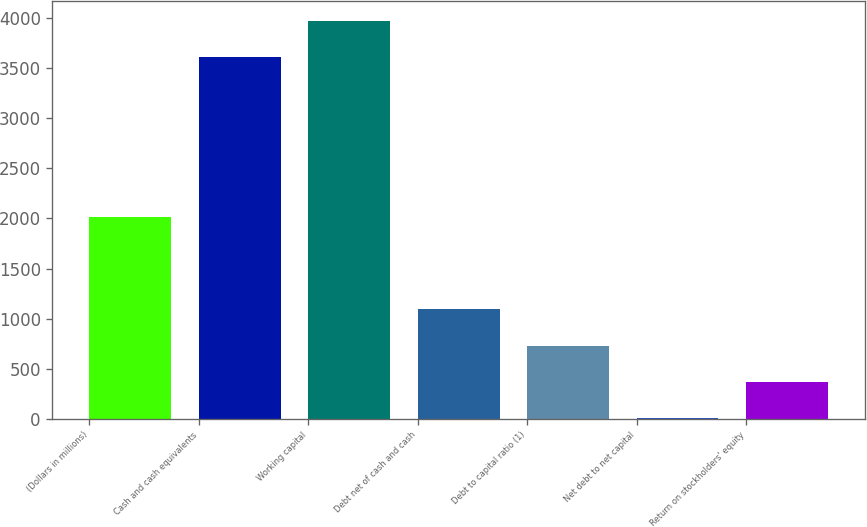Convert chart to OTSL. <chart><loc_0><loc_0><loc_500><loc_500><bar_chart><fcel>(Dollars in millions)<fcel>Cash and cash equivalents<fcel>Working capital<fcel>Debt net of cash and cash<fcel>Debt to capital ratio (1)<fcel>Net debt to net capital<fcel>Return on stockholders' equity<nl><fcel>2011<fcel>3612<fcel>3974.59<fcel>1092.87<fcel>730.28<fcel>5.1<fcel>367.69<nl></chart> 